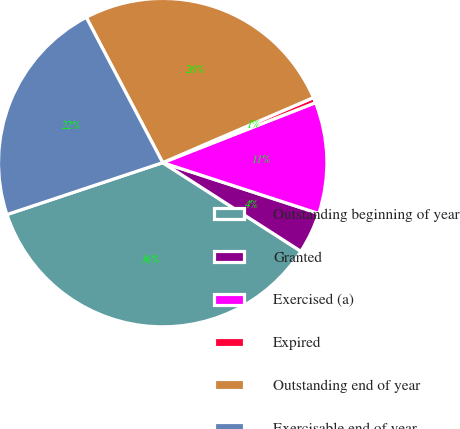<chart> <loc_0><loc_0><loc_500><loc_500><pie_chart><fcel>Outstanding beginning of year<fcel>Granted<fcel>Exercised (a)<fcel>Expired<fcel>Outstanding end of year<fcel>Exercisable end of year<nl><fcel>35.8%<fcel>4.06%<fcel>10.97%<fcel>0.53%<fcel>26.22%<fcel>22.41%<nl></chart> 